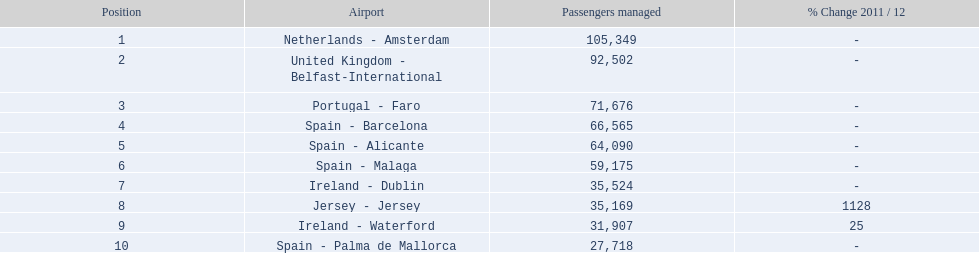What are all of the airports? Netherlands - Amsterdam, United Kingdom - Belfast-International, Portugal - Faro, Spain - Barcelona, Spain - Alicante, Spain - Malaga, Ireland - Dublin, Jersey - Jersey, Ireland - Waterford, Spain - Palma de Mallorca. How many passengers have they handled? 105,349, 92,502, 71,676, 66,565, 64,090, 59,175, 35,524, 35,169, 31,907, 27,718. And which airport has handled the most passengers? Netherlands - Amsterdam. 